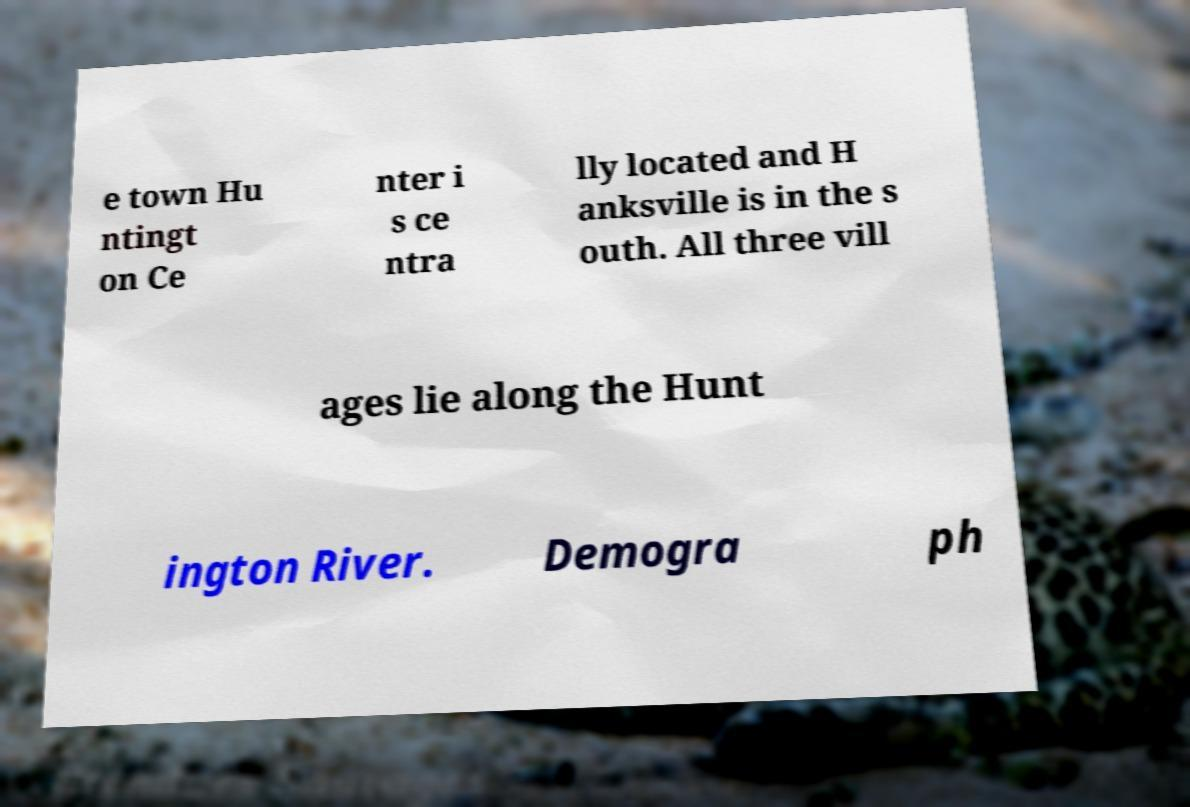I need the written content from this picture converted into text. Can you do that? e town Hu ntingt on Ce nter i s ce ntra lly located and H anksville is in the s outh. All three vill ages lie along the Hunt ington River. Demogra ph 